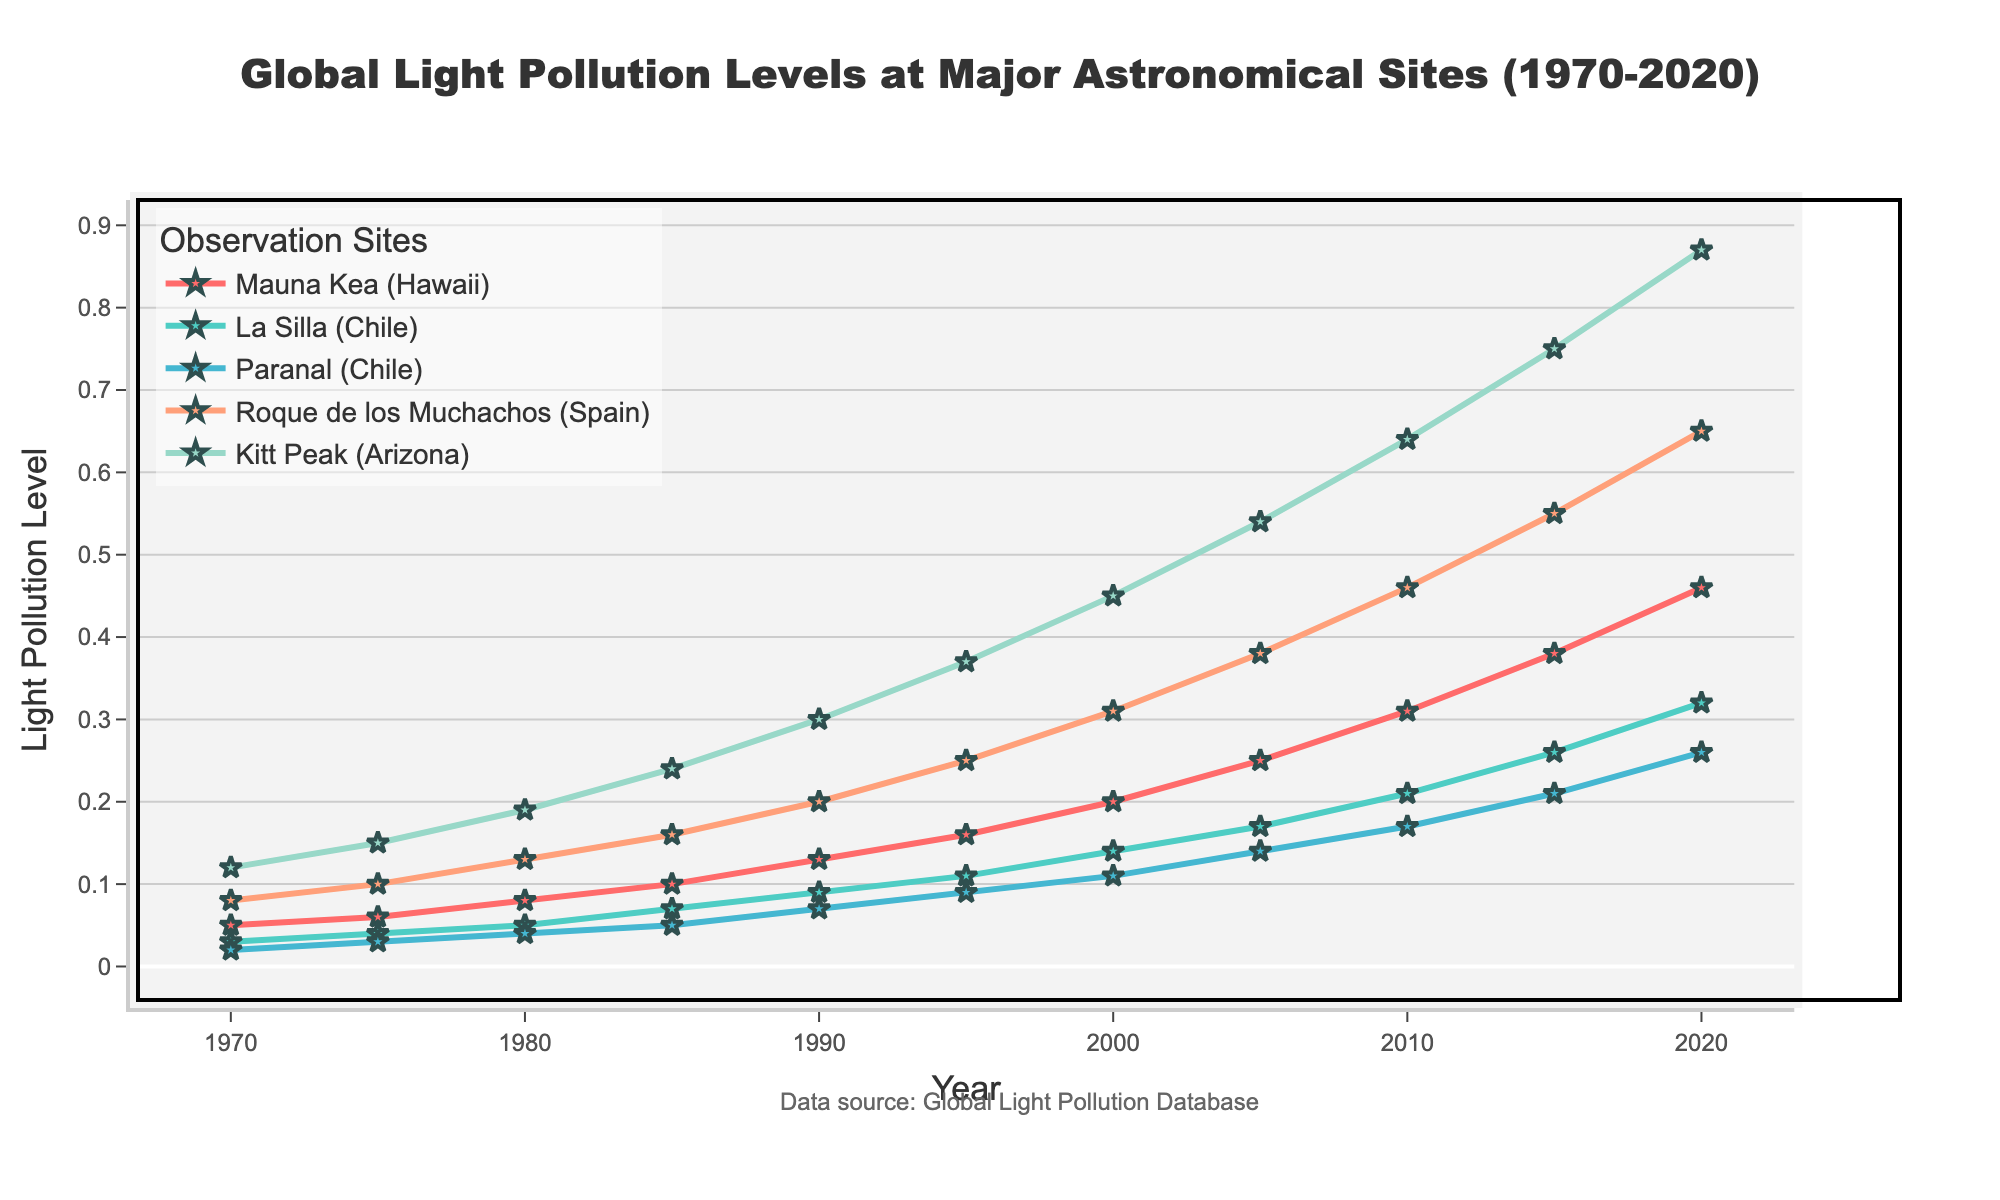Which site had the lowest light pollution level in 1970? By examining the data points at the year 1970, we see the lowest value among Mauna Kea (0.05), La Silla (0.03), Paranal (0.02), Roque de los Muchachos (0.08), and Kitt Peak (0.12) is for Paranal.
Answer: Paranal How much did the light pollution level at Kitt Peak increase from 1970 to 2020? The light pollution level at Kitt Peak in 1970 was 0.12 and in 2020 it was 0.87. The increase can be calculated as 0.87 - 0.12 = 0.75.
Answer: 0.75 Which site showed the most significant increase in light pollution level from 1970 to 2020? To determine this, we calculate the increase for each site: Mauna Kea (0.46 - 0.05 = 0.41), La Silla (0.32 - 0.03 = 0.29), Paranal (0.26 - 0.02 = 0.24), Roque de los Muchachos (0.65 - 0.08 = 0.57), and Kitt Peak (0.87 - 0.12 = 0.75). Kitt Peak shows the highest increase of 0.75.
Answer: Kitt Peak Between 1980 and 2000, which site had the smallest increase in light pollution level? Let's calculate the increase for each site between 1980 and 2000: Mauna Kea (0.20 - 0.08 = 0.12), La Silla (0.14 - 0.05 = 0.09), Paranal (0.11 - 0.04 = 0.07), Roque de los Muchachos (0.31 - 0.13 = 0.18), and Kitt Peak (0.45 - 0.19 = 0.26). Paranal has the smallest increase of 0.07.
Answer: Paranal In which year did Mauna Kea exceed a light pollution level of 0.3? Observing the trend for Mauna Kea, we see it exceeded 0.3 in the year 2010 when it was recorded at 0.31.
Answer: 2010 Which observation site has the steepest slope between the years 2000 and 2020? To determine the steepest slope, we compute the slope for each site: Mauna Kea ((0.46-0.20)/20 = 0.013), La Silla ((0.32-0.14)/20 = 0.009), Paranal ((0.26-0.11)/20 = 0.0075), Roque de los Muchachos ((0.65-0.31)/20 = 0.017), Kitt Peak ((0.87-0.45)/20 = 0.021). Kitt Peak has the steepest slope of 0.021.
Answer: Kitt Peak In 1995, which site had light pollution levels closer to average? First, find the average for 1995: (0.16 + 0.11 + 0.09 + 0.25 + 0.37)/5 = 0.196. Comparing values: Mauna Kea (0.16), La Silla (0.11), Paranal (0.09), Roque de los Muchachos (0.25), Kitt Peak (0.37). La Silla (0.11) is closest to the average of 0.196.
Answer: La Silla At what rate did the light pollution level change at Paranal between 1985 and 2015? Calculate the rate of change: (0.21 - 0.05)/30 = 0.0053 per year.
Answer: 0.0053 per year Which site's pollution trends upward most consistently over the 50 years? Analyzing trends visually, all sites show an upward trend, but Kitt Peak shows the most consistent and steep rise over the 50 years.
Answer: Kitt Peak 